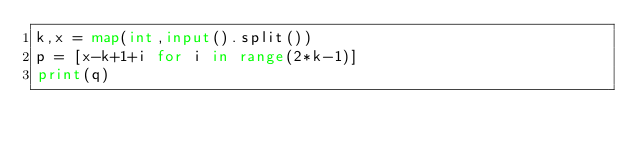<code> <loc_0><loc_0><loc_500><loc_500><_Python_>k,x = map(int,input().split())
p = [x-k+1+i for i in range(2*k-1)]
print(q)</code> 